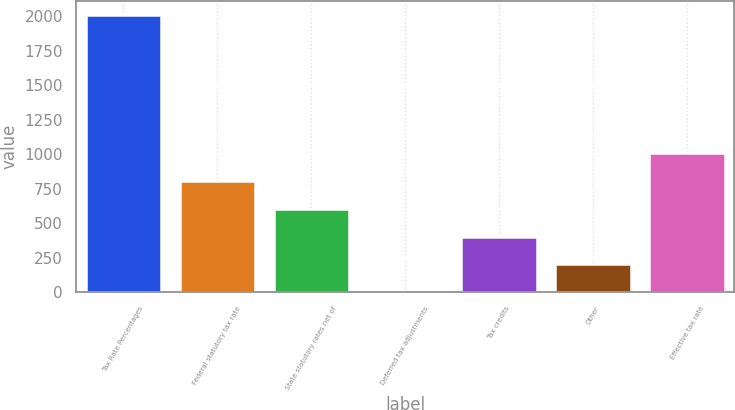Convert chart. <chart><loc_0><loc_0><loc_500><loc_500><bar_chart><fcel>Tax Rate Percentages<fcel>Federal statutory tax rate<fcel>State statutory rates net of<fcel>Deferred tax adjustments<fcel>Tax credits<fcel>Other<fcel>Effective tax rate<nl><fcel>2013<fcel>805.26<fcel>603.97<fcel>0.1<fcel>402.68<fcel>201.39<fcel>1006.55<nl></chart> 